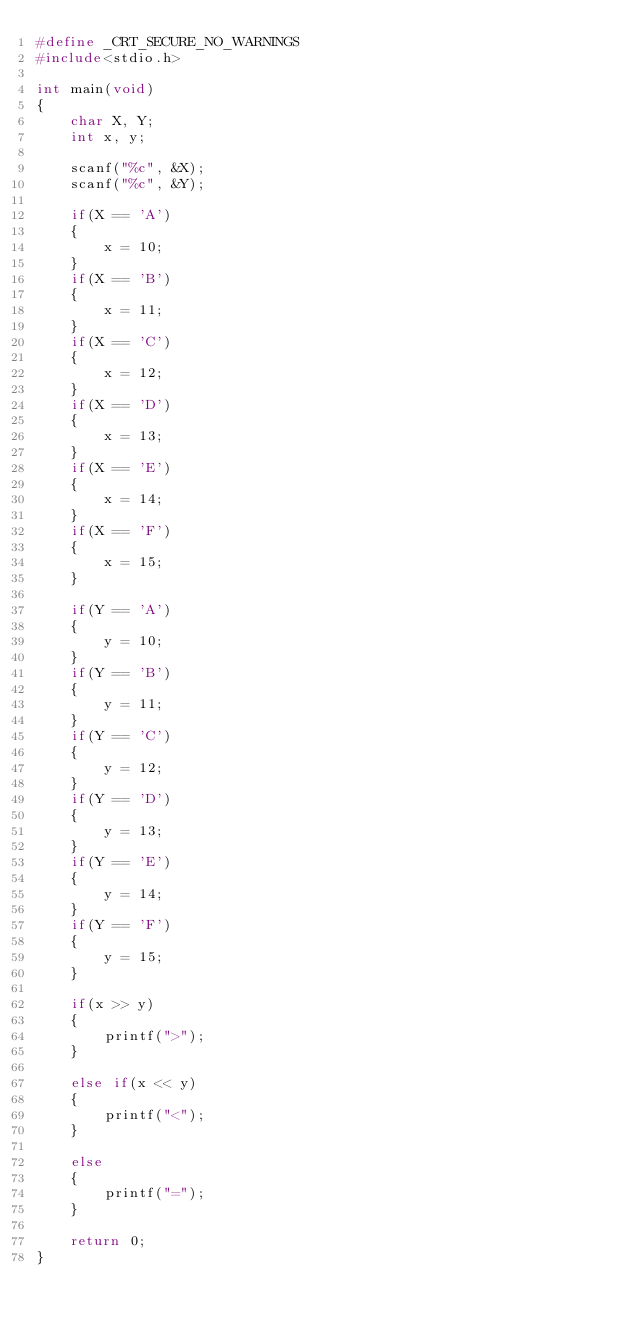<code> <loc_0><loc_0><loc_500><loc_500><_C_>#define _CRT_SECURE_NO_WARNINGS
#include<stdio.h>

int main(void)
{
    char X, Y;
    int x, y;

    scanf("%c", &X);
    scanf("%c", &Y);

    if(X == 'A')
    {
        x = 10;
    }
    if(X == 'B')
    {
        x = 11;
    }
    if(X == 'C')
    {
        x = 12;
    }
    if(X == 'D')
    {
        x = 13;
    }
    if(X == 'E')
    {
        x = 14;
    }
    if(X == 'F')
    {
        x = 15;
    }

    if(Y == 'A')
    {
        y = 10;
    }
    if(Y == 'B')
    {
        y = 11;
    }
    if(Y == 'C')
    {
        y = 12;
    }
    if(Y == 'D')
    {
        y = 13;
    }
    if(Y == 'E')
    {
        y = 14;
    }
    if(Y == 'F')
    {
        y = 15;
    }

    if(x >> y)
    {
        printf(">");
    }

    else if(x << y)
    {
        printf("<");
    }

    else
    {
        printf("=");
    }

    return 0;
}</code> 